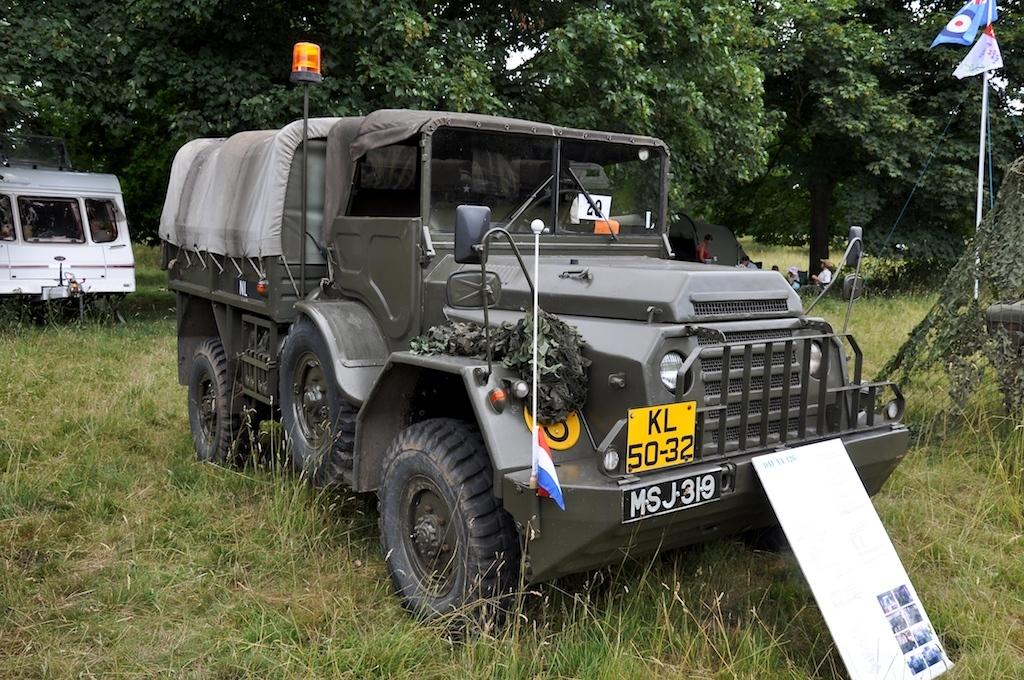What type of vegetation can be seen in the image? There is grass in the image. What object is present in the image that might be used for displaying information or announcements? There is a board in the image. What items in the image are used to represent a group or organization? There are flags in the image. What structures are present in the image that might be used to support the flags or other objects? There are poles in the image. What type of transportation is visible in the image? There are vehicles in the image. What type of temporary shelter is present in the image? There is a tent in the image. Who or what is present in the image that might interact with the environment or objects? There are people in the image. What can be seen in the background of the image that provides a sense of the natural environment? There are trees in the background of the image. Can you tell me how many brushes are used to paint the ocean scene in the image? There is no ocean scene or brushes present in the image. What degree of difficulty is required to climb the degree in the image? There is no degree present in the image, and therefore no difficulty level to climb. 